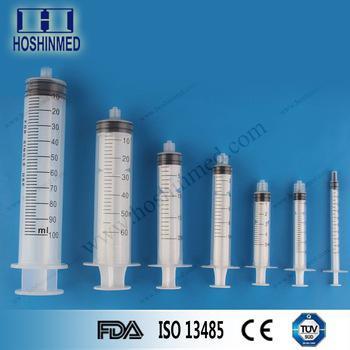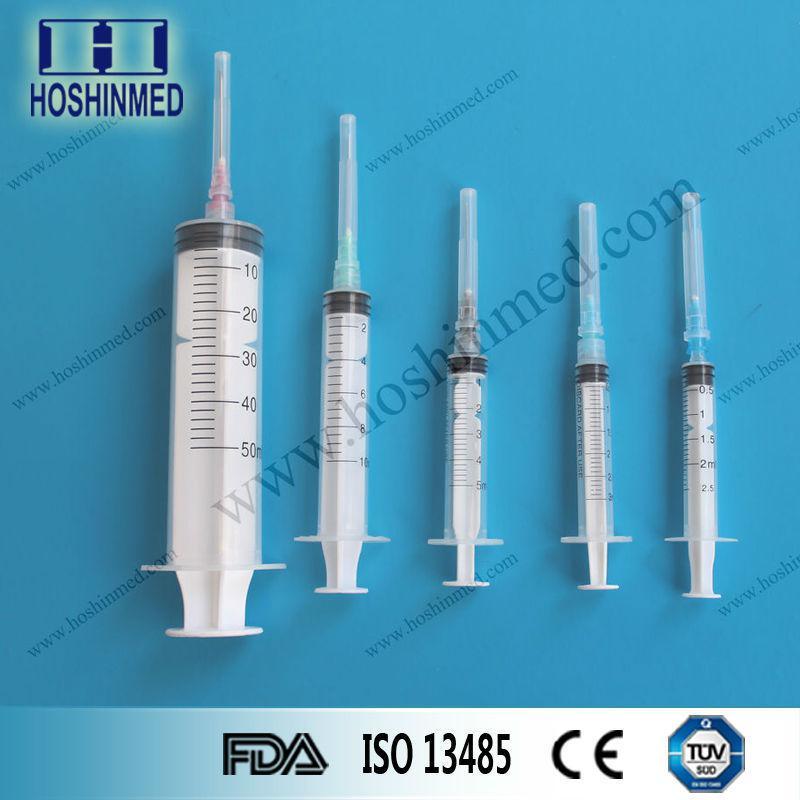The first image is the image on the left, the second image is the image on the right. Analyze the images presented: Is the assertion "Each image shows syringes arranged in descending order of volume from left to right, on a blue background." valid? Answer yes or no. Yes. The first image is the image on the left, the second image is the image on the right. Evaluate the accuracy of this statement regarding the images: "The left and right image contains the same number of syringes.". Is it true? Answer yes or no. No. 